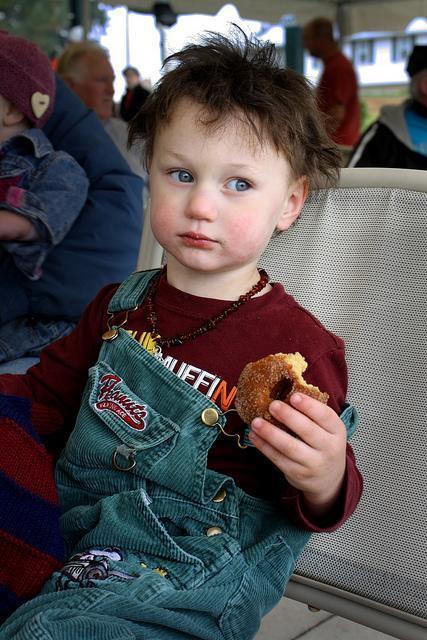How many people are in the photo?
Give a very brief answer. 6. How many clocks can be seen?
Give a very brief answer. 0. 